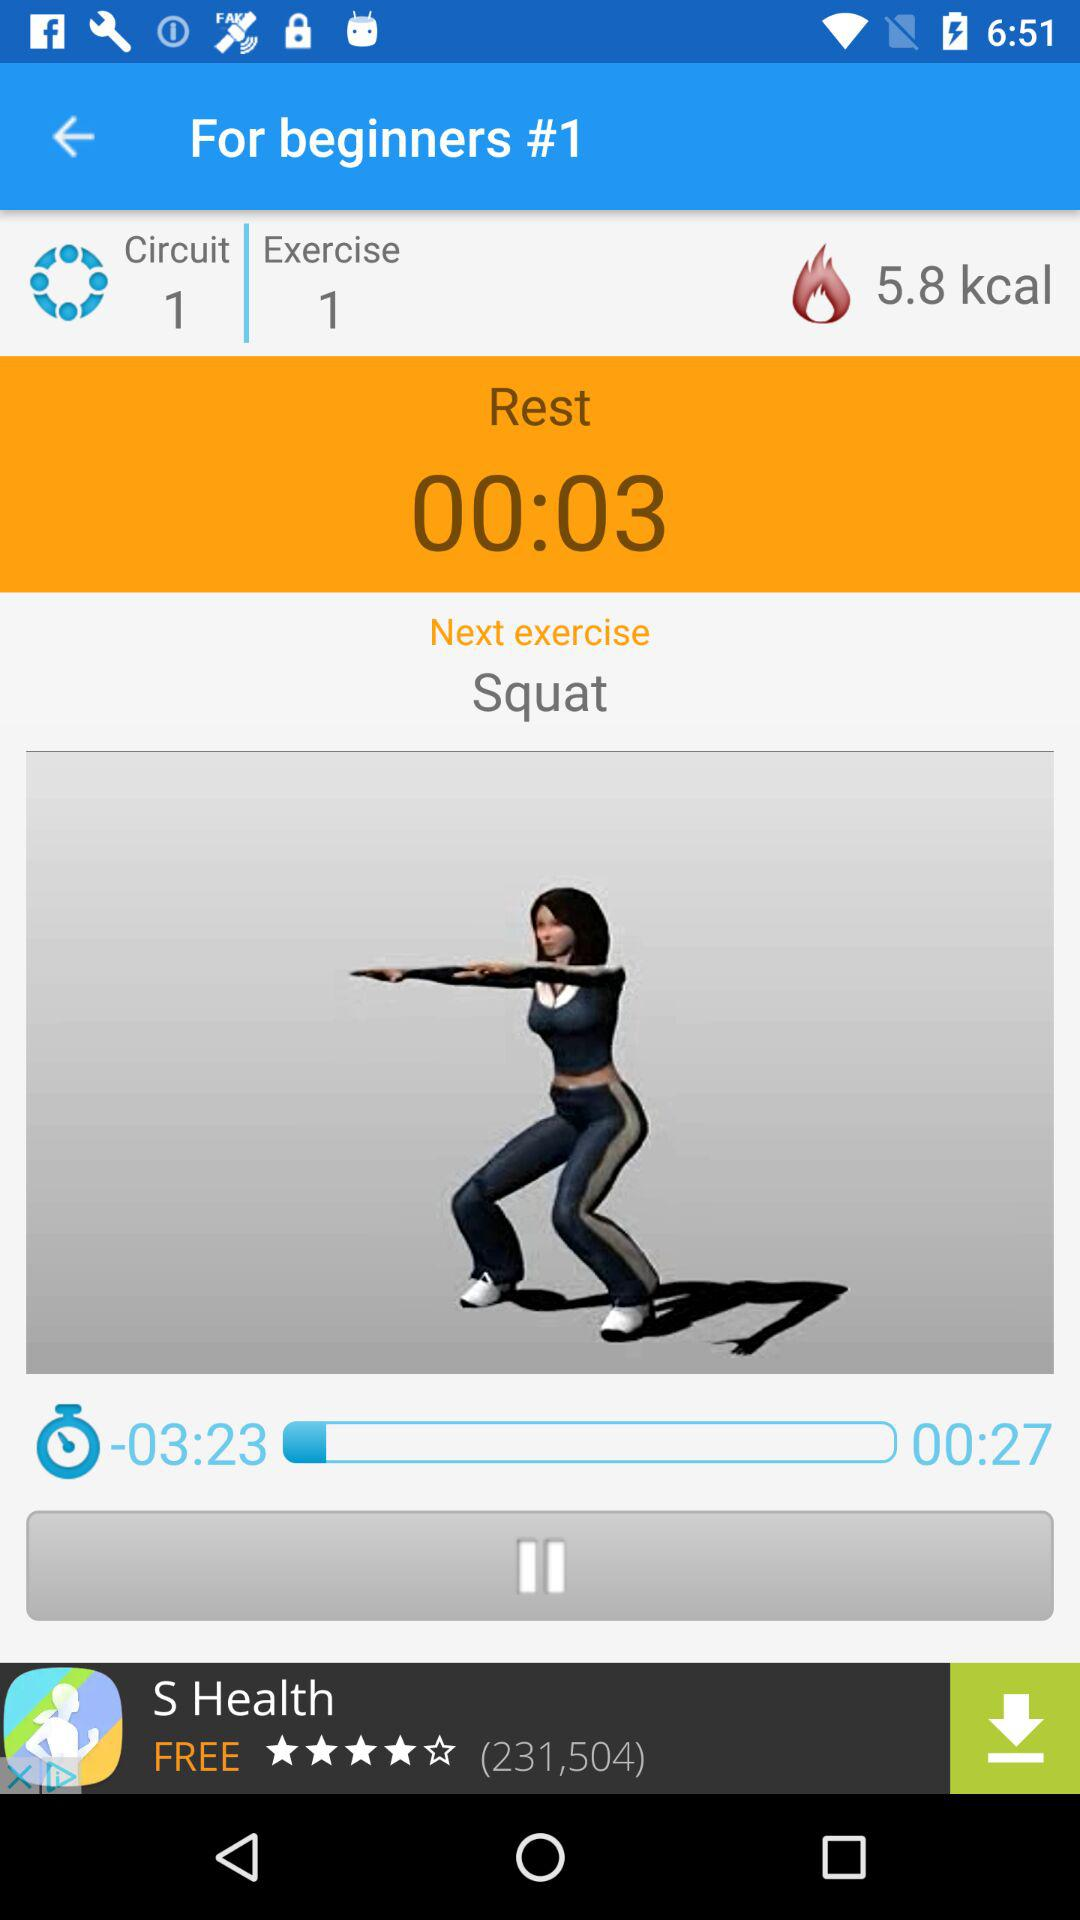What exercise number is this? This is exercise number 1. 